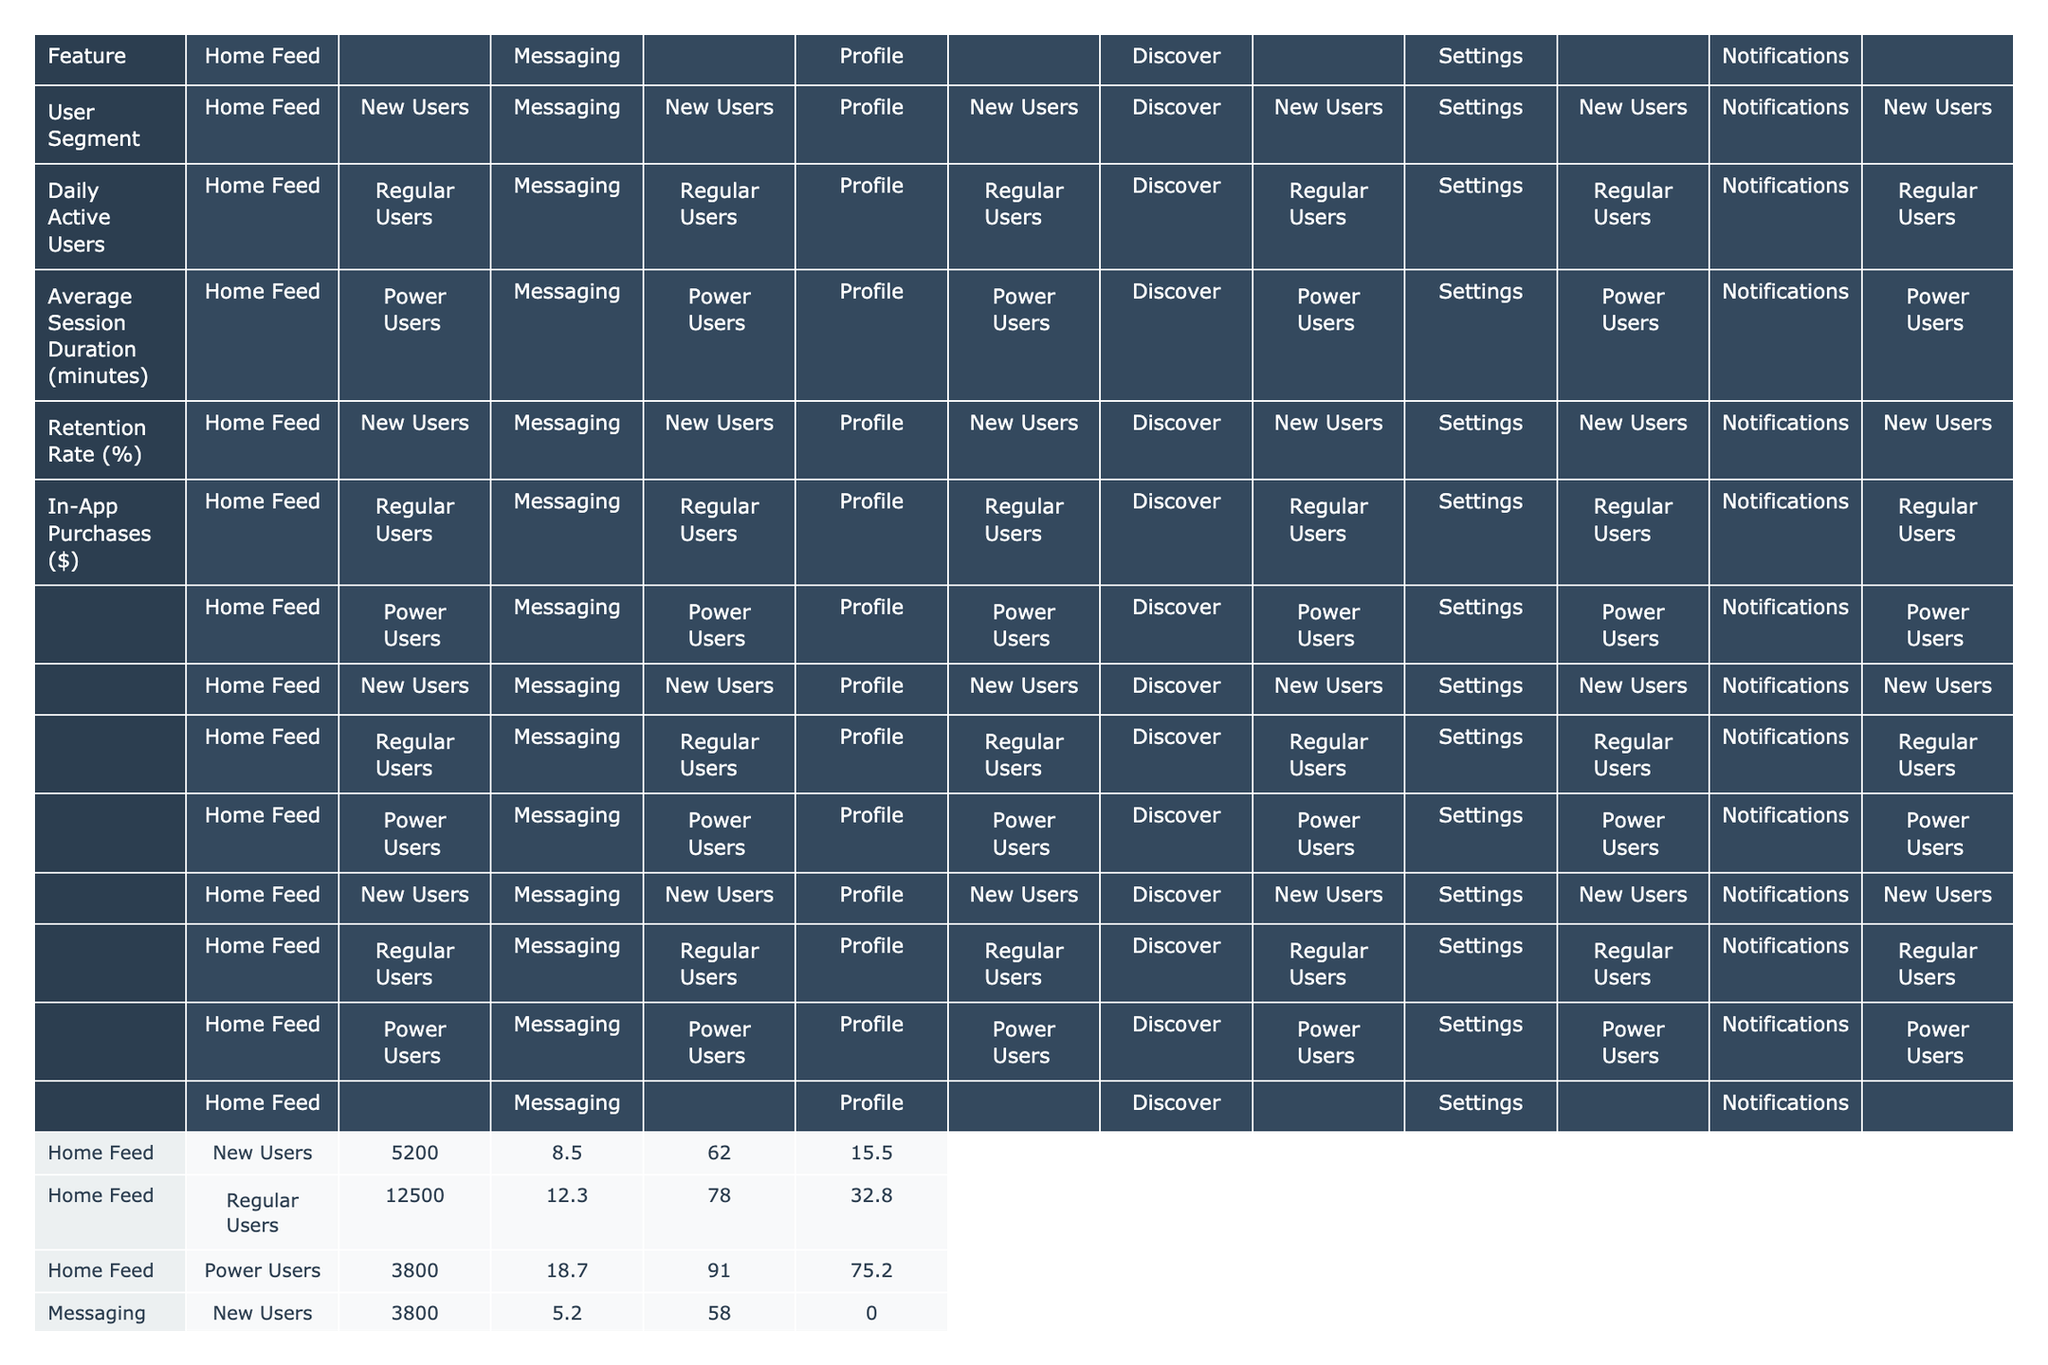What is the average session duration for Regular Users in the Home Feed? The average session duration for Regular Users in the Home Feed is 12.3 minutes, as indicated directly in the table under that specific user segment.
Answer: 12.3 minutes What is the retention rate of Power Users in the Messaging feature? The retention rate for Power Users in the Messaging feature is 95%, as shown in the table for that user segment and feature combination.
Answer: 95% How many Daily Active Users does the Discover feature have for New Users? The number of Daily Active Users for New Users in the Discover feature is 4,100, which can be found directly in the table.
Answer: 4,100 What is the total in-app purchases amount made by Regular Users across all features? Adding the in-app purchases for Regular Users: 32.80 + 18.90 + 27.50 + 0 + 12.40 = 91.60; the total is calculated by summing each of the significant values corresponding to Regular Users in the respective features.
Answer: $91.60 Is the average session duration for Power Users in the Profile feature greater than 10 minutes? The average session duration for Power Users in the Profile feature is 9.8 minutes, which is less than 10 minutes; therefore, the statement is false based on the data provided in the table.
Answer: No What is the difference in Daily Active Users between Regular Users and New Users in the Notifications feature? For the Notifications feature, Regular Users have 11,800 Daily Active Users and New Users have 4,800 Daily Active Users. The difference is calculated as 11,800 - 4,800 = 7,000.
Answer: 7,000 What is the retention rate for New Users in the Profile feature, and how does it compare to the retention rate for New Users in the Settings feature? The retention rate for New Users in the Profile feature is 45%, while for New Users in the Settings feature, it is 30%. The Profile feature's retention rate is higher by 15 percentage points (45% - 30%).
Answer: 15% Which feature has the highest in-app purchases for Power Users? By examining the in-app purchases for Power Users, the Home Feed has $75.20, the highest amount compared to other features noted in the table.
Answer: Home Feed What is the average retention rate across all user segments for the Messaging feature? The retention rates for the Messaging feature by user segment are: New Users (58%), Regular Users (82%), and Power Users (95%). The average is (58 + 82 + 95) / 3 = 78.33%.
Answer: 78.33% Is it true that Regular Users in the Home Feed have a higher average session duration than New Users in the Messaging feature? Yes, Regular Users in Home Feed have an average session duration of 12.3 minutes, which is greater than the 5.2 minutes for New Users in Messaging; thus, the statement is true.
Answer: Yes 